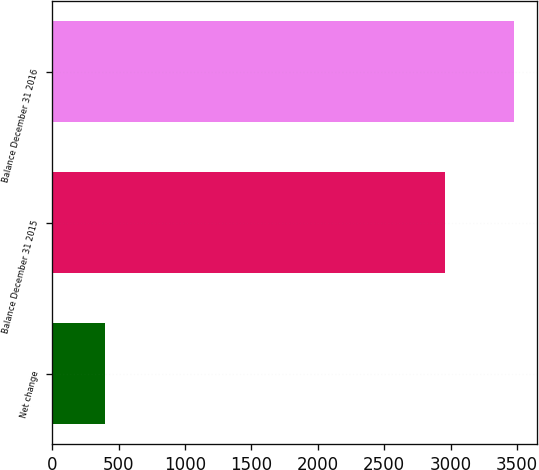Convert chart to OTSL. <chart><loc_0><loc_0><loc_500><loc_500><bar_chart><fcel>Net change<fcel>Balance December 31 2015<fcel>Balance December 31 2016<nl><fcel>394<fcel>2956<fcel>3480<nl></chart> 